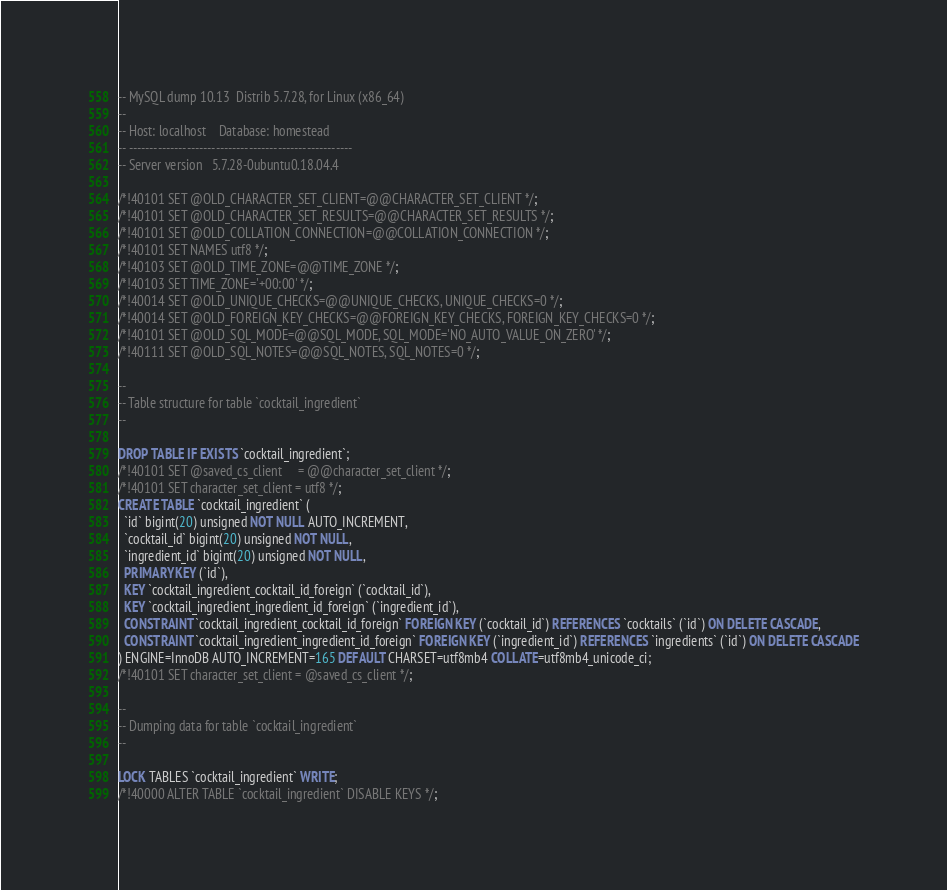Convert code to text. <code><loc_0><loc_0><loc_500><loc_500><_SQL_>-- MySQL dump 10.13  Distrib 5.7.28, for Linux (x86_64)
--
-- Host: localhost    Database: homestead
-- ------------------------------------------------------
-- Server version	5.7.28-0ubuntu0.18.04.4

/*!40101 SET @OLD_CHARACTER_SET_CLIENT=@@CHARACTER_SET_CLIENT */;
/*!40101 SET @OLD_CHARACTER_SET_RESULTS=@@CHARACTER_SET_RESULTS */;
/*!40101 SET @OLD_COLLATION_CONNECTION=@@COLLATION_CONNECTION */;
/*!40101 SET NAMES utf8 */;
/*!40103 SET @OLD_TIME_ZONE=@@TIME_ZONE */;
/*!40103 SET TIME_ZONE='+00:00' */;
/*!40014 SET @OLD_UNIQUE_CHECKS=@@UNIQUE_CHECKS, UNIQUE_CHECKS=0 */;
/*!40014 SET @OLD_FOREIGN_KEY_CHECKS=@@FOREIGN_KEY_CHECKS, FOREIGN_KEY_CHECKS=0 */;
/*!40101 SET @OLD_SQL_MODE=@@SQL_MODE, SQL_MODE='NO_AUTO_VALUE_ON_ZERO' */;
/*!40111 SET @OLD_SQL_NOTES=@@SQL_NOTES, SQL_NOTES=0 */;

--
-- Table structure for table `cocktail_ingredient`
--

DROP TABLE IF EXISTS `cocktail_ingredient`;
/*!40101 SET @saved_cs_client     = @@character_set_client */;
/*!40101 SET character_set_client = utf8 */;
CREATE TABLE `cocktail_ingredient` (
  `id` bigint(20) unsigned NOT NULL AUTO_INCREMENT,
  `cocktail_id` bigint(20) unsigned NOT NULL,
  `ingredient_id` bigint(20) unsigned NOT NULL,
  PRIMARY KEY (`id`),
  KEY `cocktail_ingredient_cocktail_id_foreign` (`cocktail_id`),
  KEY `cocktail_ingredient_ingredient_id_foreign` (`ingredient_id`),
  CONSTRAINT `cocktail_ingredient_cocktail_id_foreign` FOREIGN KEY (`cocktail_id`) REFERENCES `cocktails` (`id`) ON DELETE CASCADE,
  CONSTRAINT `cocktail_ingredient_ingredient_id_foreign` FOREIGN KEY (`ingredient_id`) REFERENCES `ingredients` (`id`) ON DELETE CASCADE
) ENGINE=InnoDB AUTO_INCREMENT=165 DEFAULT CHARSET=utf8mb4 COLLATE=utf8mb4_unicode_ci;
/*!40101 SET character_set_client = @saved_cs_client */;

--
-- Dumping data for table `cocktail_ingredient`
--

LOCK TABLES `cocktail_ingredient` WRITE;
/*!40000 ALTER TABLE `cocktail_ingredient` DISABLE KEYS */;</code> 